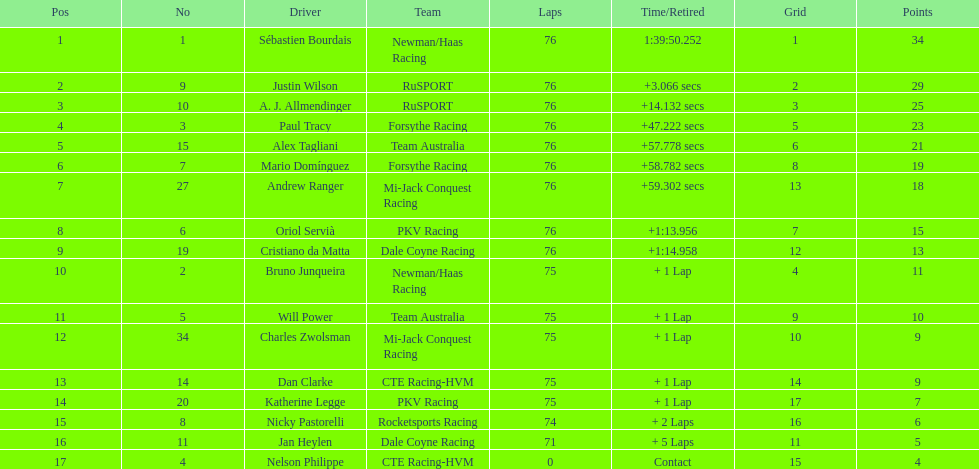How many positions are held by canada? 3. 